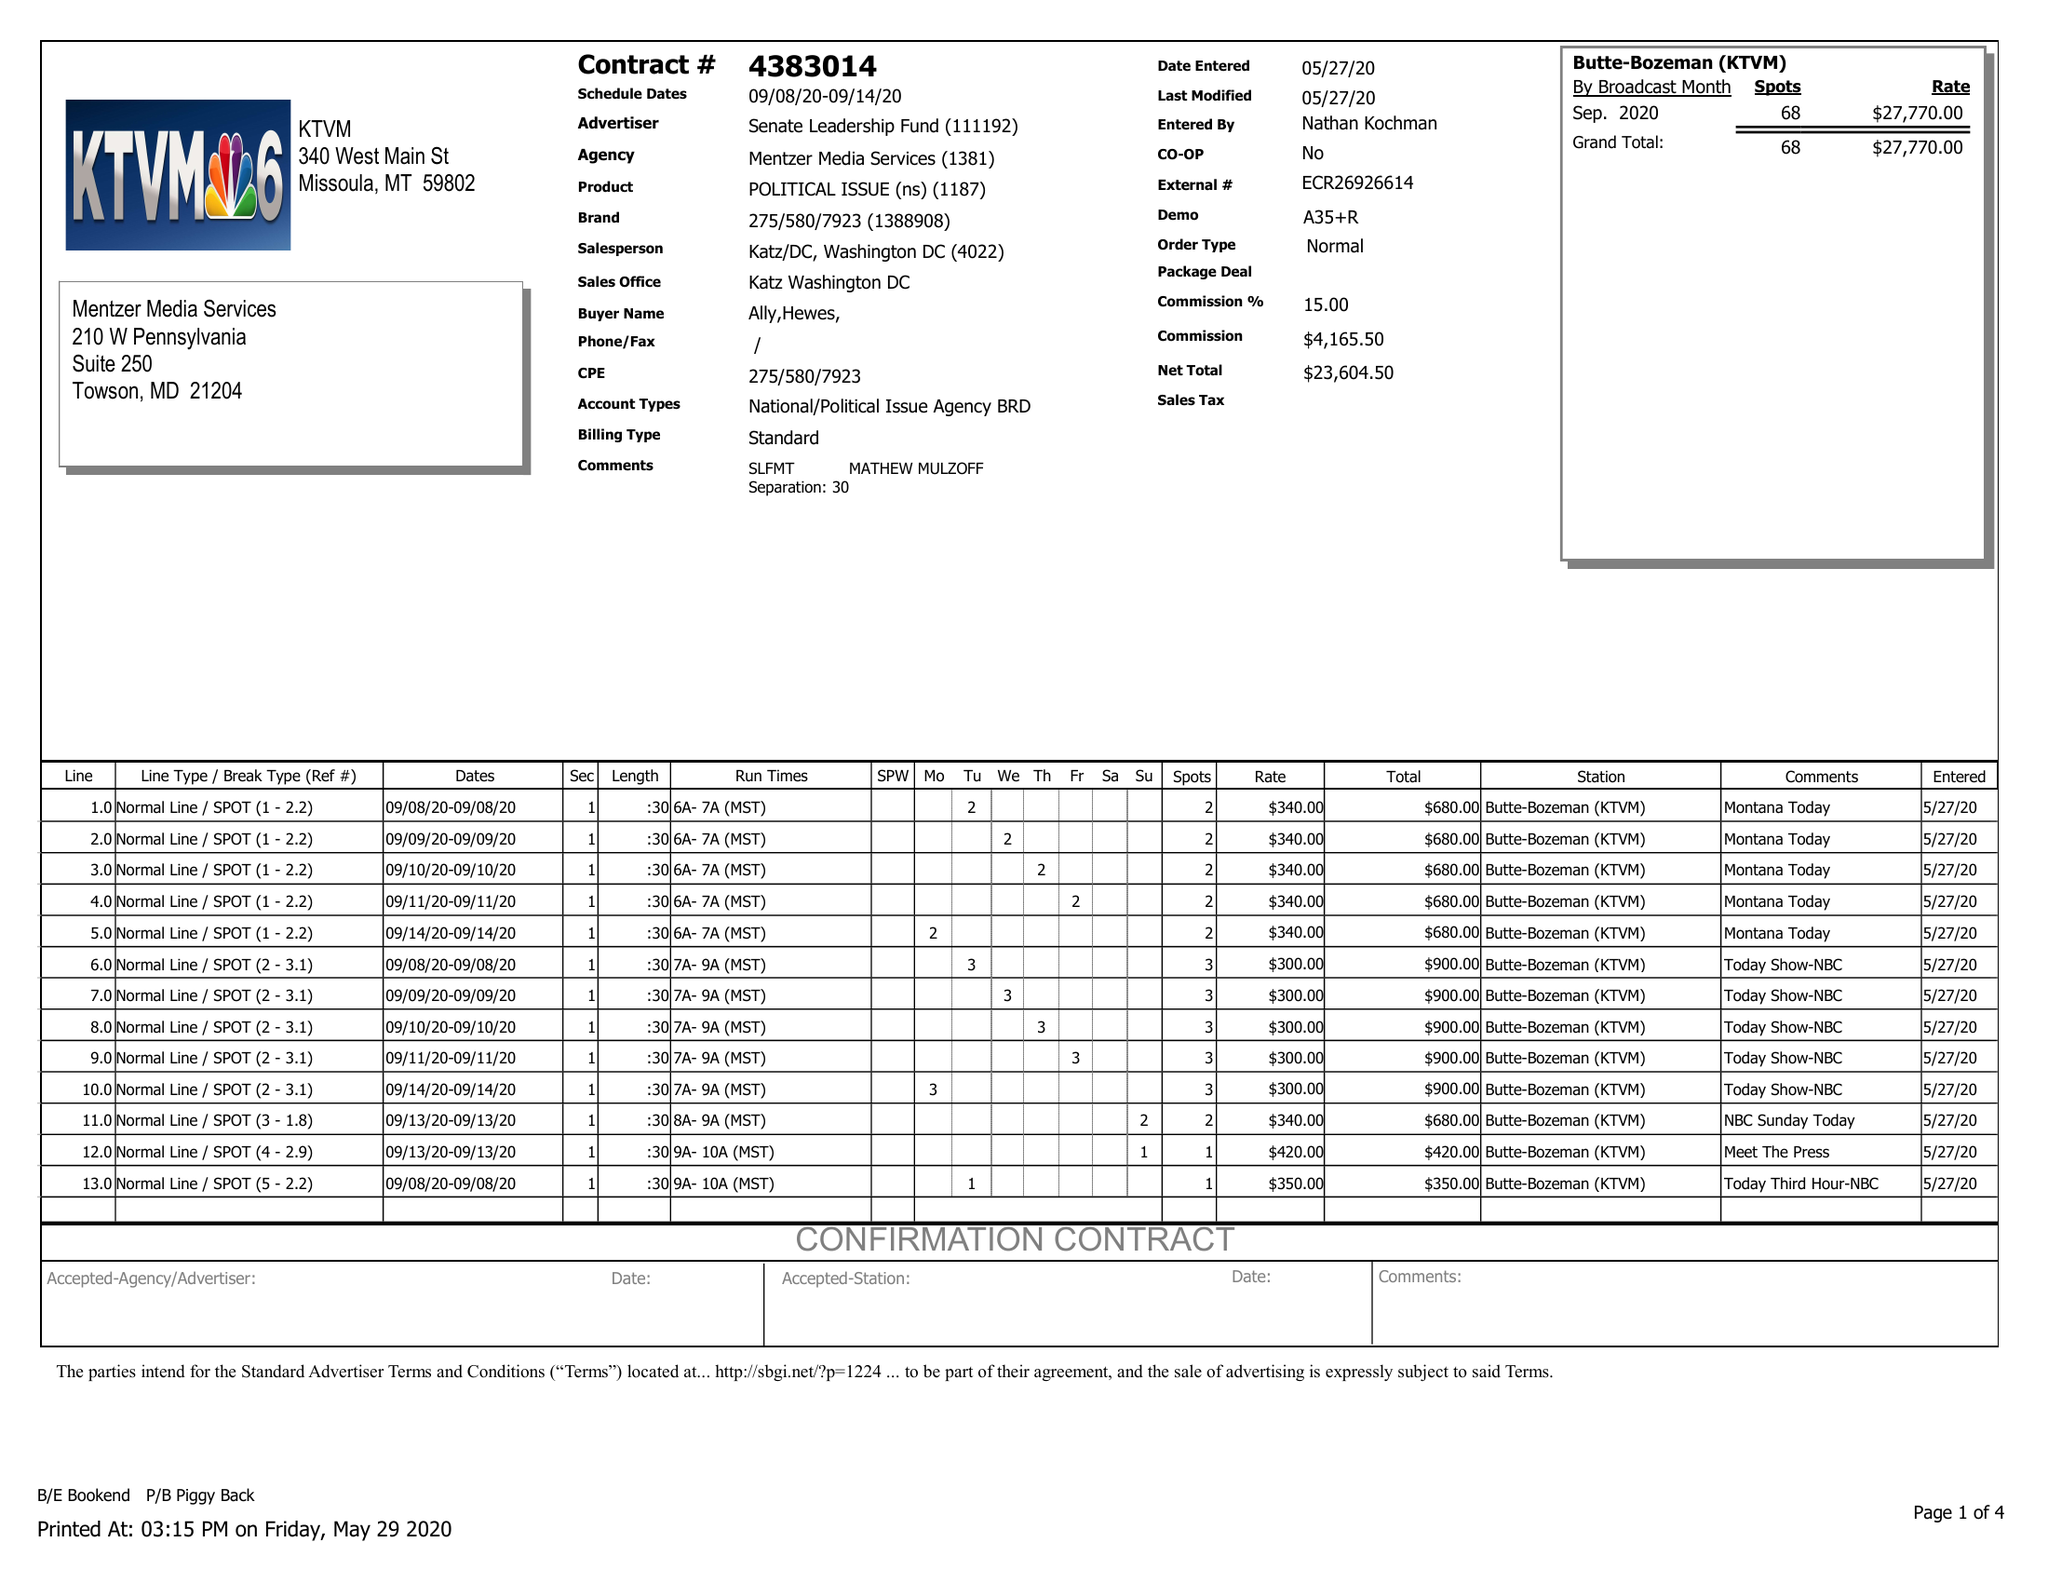What is the value for the contract_num?
Answer the question using a single word or phrase. 4383014 